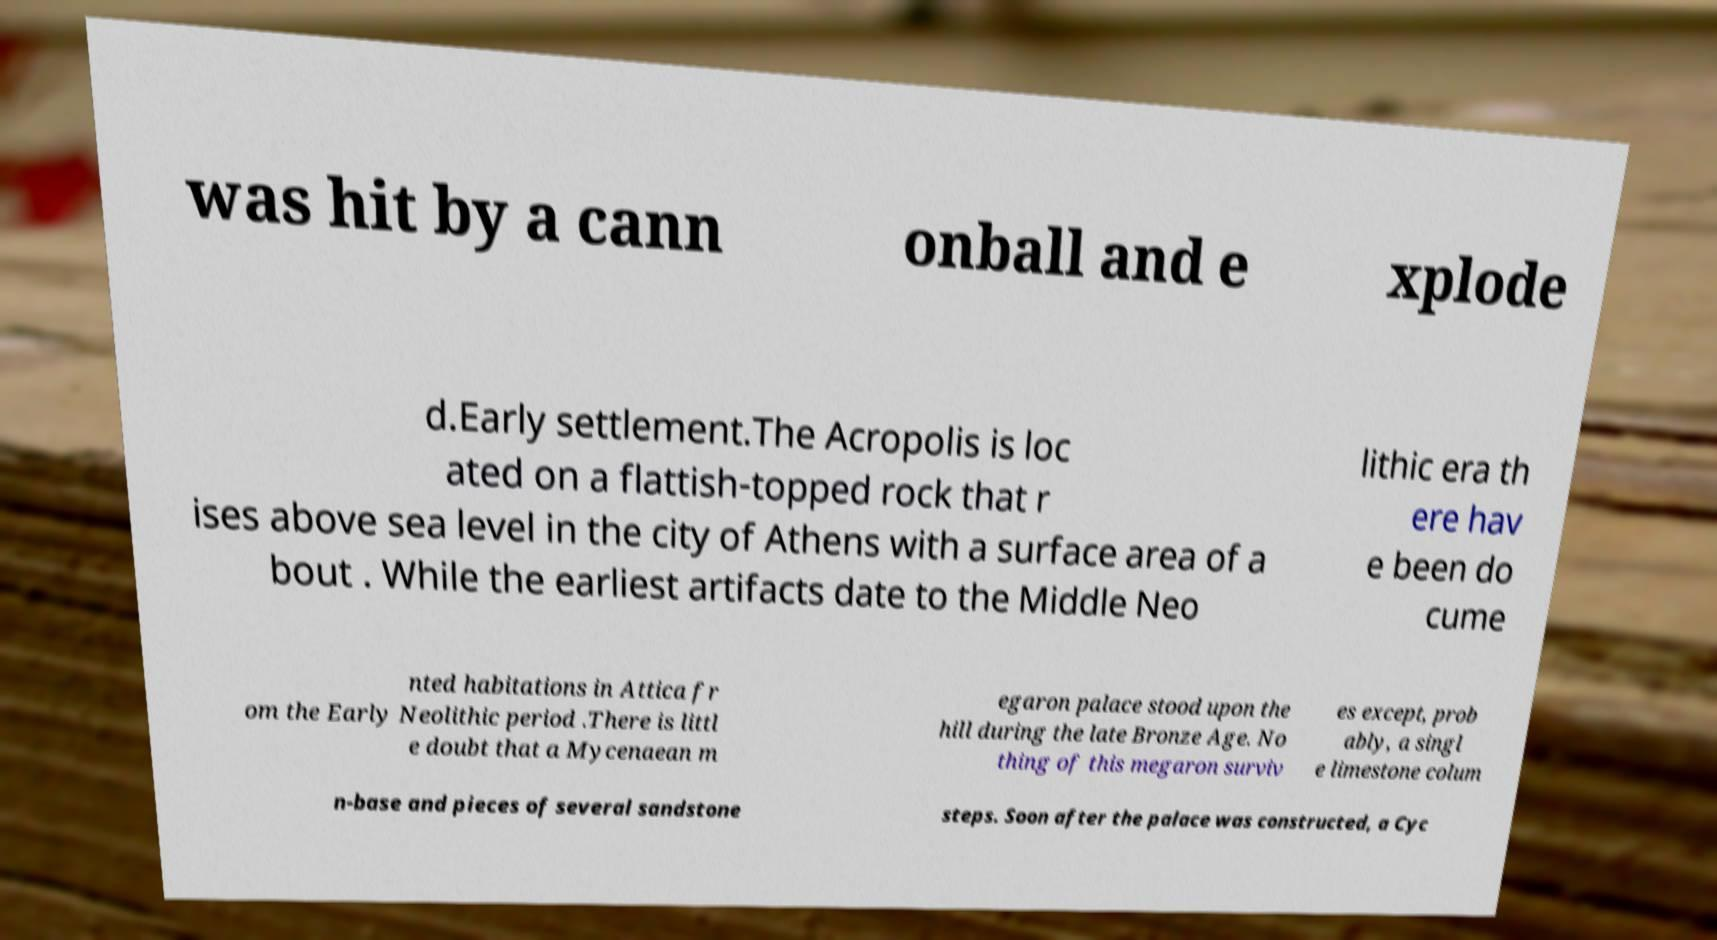There's text embedded in this image that I need extracted. Can you transcribe it verbatim? was hit by a cann onball and e xplode d.Early settlement.The Acropolis is loc ated on a flattish-topped rock that r ises above sea level in the city of Athens with a surface area of a bout . While the earliest artifacts date to the Middle Neo lithic era th ere hav e been do cume nted habitations in Attica fr om the Early Neolithic period .There is littl e doubt that a Mycenaean m egaron palace stood upon the hill during the late Bronze Age. No thing of this megaron surviv es except, prob ably, a singl e limestone colum n-base and pieces of several sandstone steps. Soon after the palace was constructed, a Cyc 